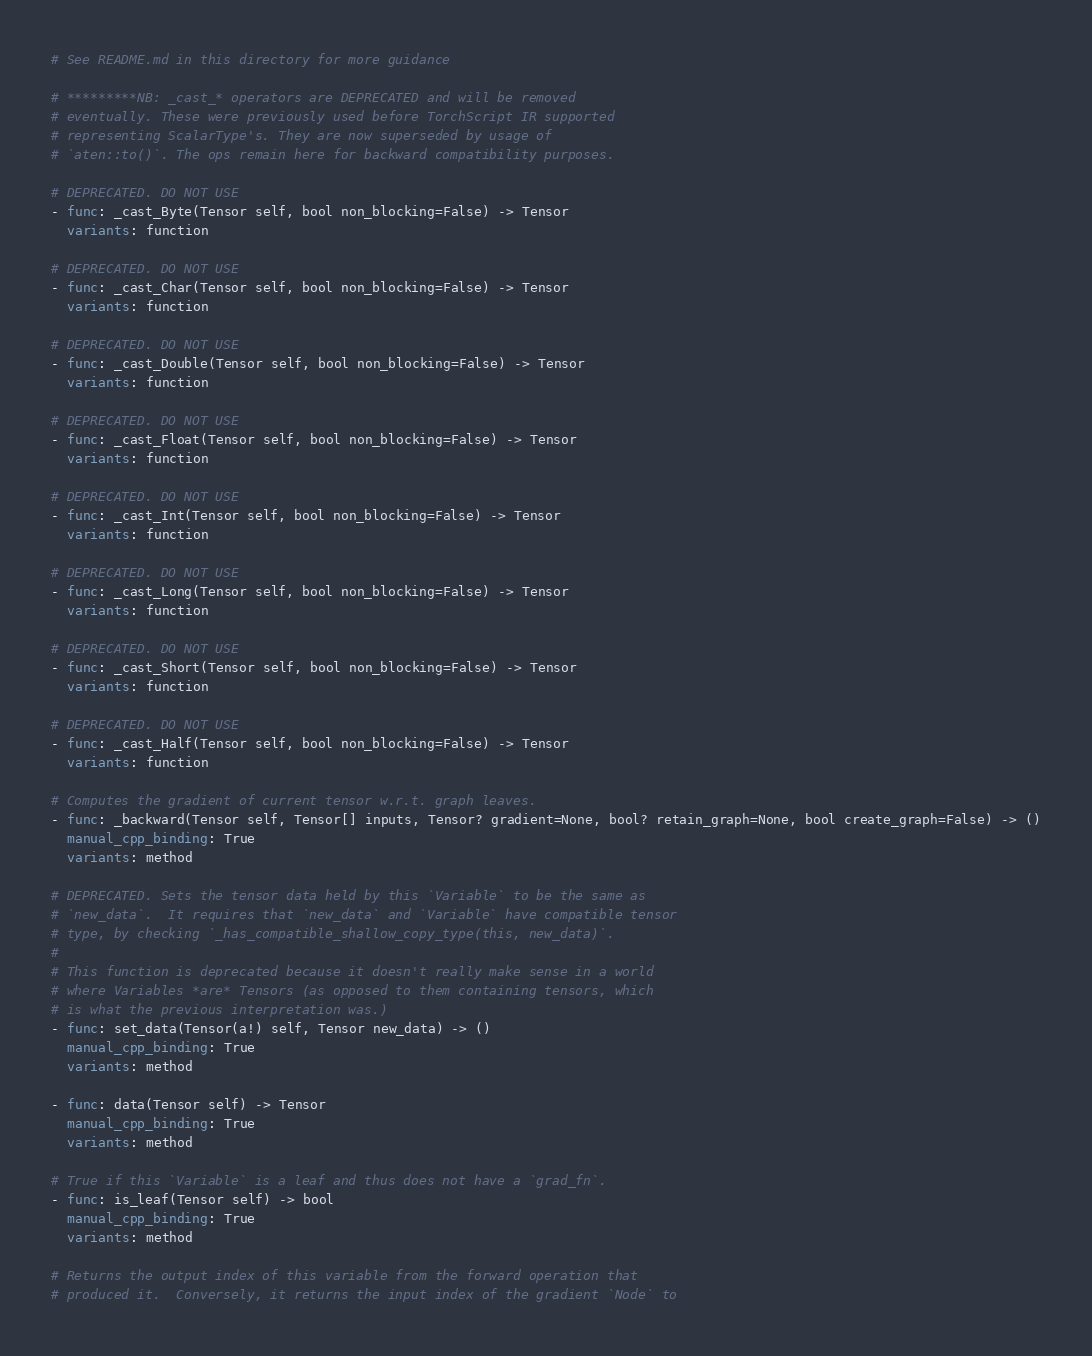<code> <loc_0><loc_0><loc_500><loc_500><_YAML_># See README.md in this directory for more guidance

# *********NB: _cast_* operators are DEPRECATED and will be removed
# eventually. These were previously used before TorchScript IR supported
# representing ScalarType's. They are now superseded by usage of
# `aten::to()`. The ops remain here for backward compatibility purposes.

# DEPRECATED. DO NOT USE
- func: _cast_Byte(Tensor self, bool non_blocking=False) -> Tensor
  variants: function

# DEPRECATED. DO NOT USE
- func: _cast_Char(Tensor self, bool non_blocking=False) -> Tensor
  variants: function

# DEPRECATED. DO NOT USE
- func: _cast_Double(Tensor self, bool non_blocking=False) -> Tensor
  variants: function

# DEPRECATED. DO NOT USE
- func: _cast_Float(Tensor self, bool non_blocking=False) -> Tensor
  variants: function

# DEPRECATED. DO NOT USE
- func: _cast_Int(Tensor self, bool non_blocking=False) -> Tensor
  variants: function

# DEPRECATED. DO NOT USE
- func: _cast_Long(Tensor self, bool non_blocking=False) -> Tensor
  variants: function

# DEPRECATED. DO NOT USE
- func: _cast_Short(Tensor self, bool non_blocking=False) -> Tensor
  variants: function

# DEPRECATED. DO NOT USE
- func: _cast_Half(Tensor self, bool non_blocking=False) -> Tensor
  variants: function

# Computes the gradient of current tensor w.r.t. graph leaves.
- func: _backward(Tensor self, Tensor[] inputs, Tensor? gradient=None, bool? retain_graph=None, bool create_graph=False) -> ()
  manual_cpp_binding: True
  variants: method

# DEPRECATED. Sets the tensor data held by this `Variable` to be the same as
# `new_data`.  It requires that `new_data` and `Variable` have compatible tensor
# type, by checking `_has_compatible_shallow_copy_type(this, new_data)`.
#
# This function is deprecated because it doesn't really make sense in a world
# where Variables *are* Tensors (as opposed to them containing tensors, which
# is what the previous interpretation was.)
- func: set_data(Tensor(a!) self, Tensor new_data) -> ()
  manual_cpp_binding: True
  variants: method

- func: data(Tensor self) -> Tensor
  manual_cpp_binding: True
  variants: method

# True if this `Variable` is a leaf and thus does not have a `grad_fn`.
- func: is_leaf(Tensor self) -> bool
  manual_cpp_binding: True
  variants: method

# Returns the output index of this variable from the forward operation that
# produced it.  Conversely, it returns the input index of the gradient `Node` to</code> 